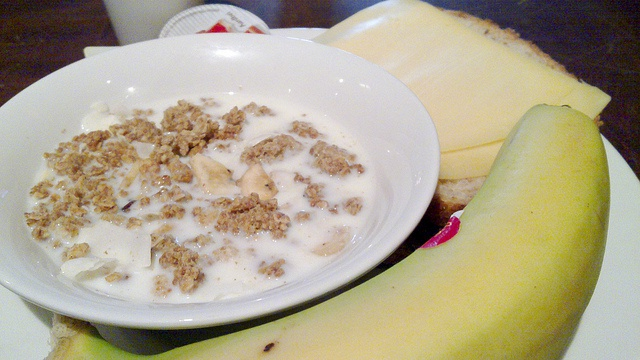Describe the objects in this image and their specific colors. I can see bowl in black, lightgray, darkgray, and tan tones, banana in black, tan, olive, and khaki tones, and sandwich in black, tan, and lightgray tones in this image. 